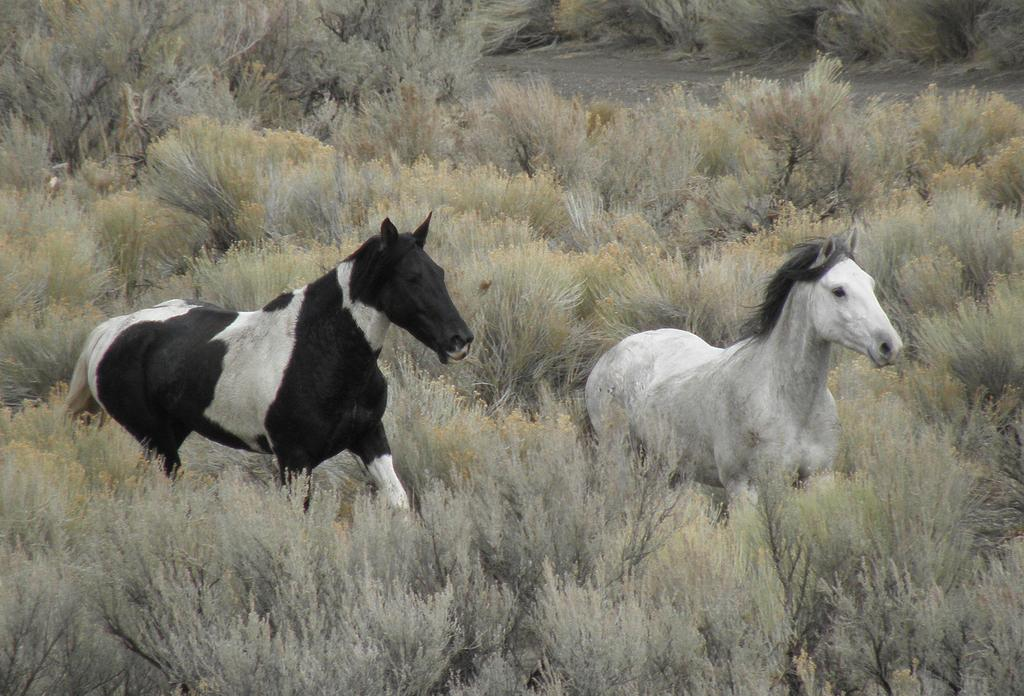What is located in the center of the image? There are animals in the center of the image. What can be seen in the background of the image? There are plants in the background of the image. What part of the image shows the ground? The ground is visible at the top of the image. What type of soup is being served in the mailbox in the image? There is no mailbox or soup present in the image. What is the weight of the animals in the image? The weight of the animals cannot be determined from the image alone. 